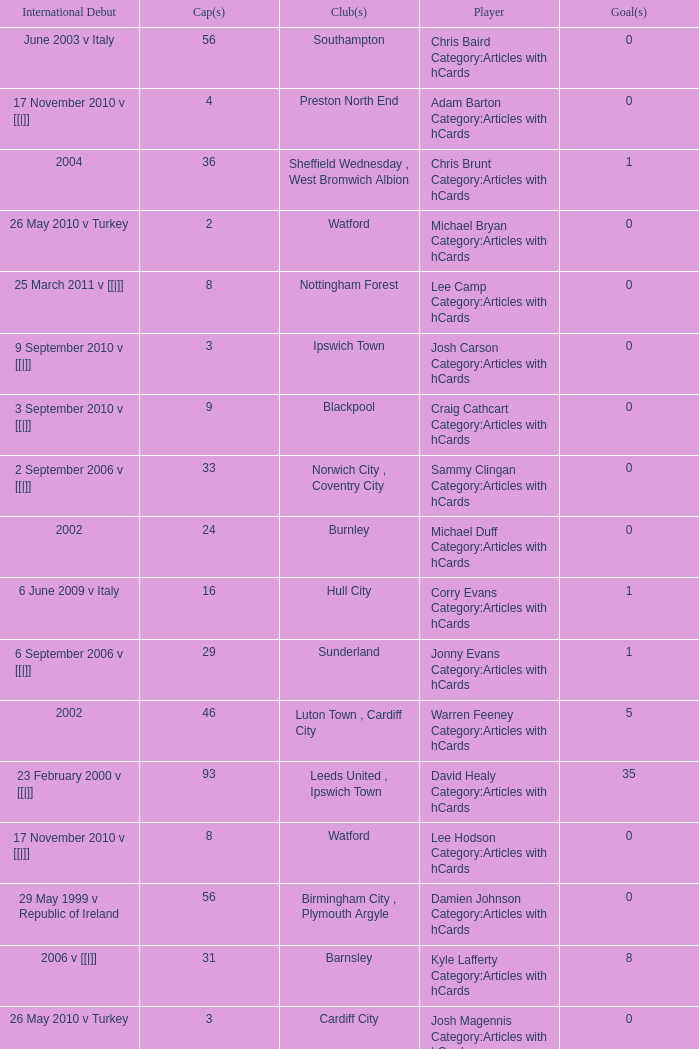How many caps figures for the Doncaster Rovers? 1.0. Help me parse the entirety of this table. {'header': ['International Debut', 'Cap(s)', 'Club(s)', 'Player', 'Goal(s)'], 'rows': [['June 2003 v Italy', '56', 'Southampton', 'Chris Baird Category:Articles with hCards', '0'], ['17 November 2010 v [[|]]', '4', 'Preston North End', 'Adam Barton Category:Articles with hCards', '0'], ['2004', '36', 'Sheffield Wednesday , West Bromwich Albion', 'Chris Brunt Category:Articles with hCards', '1'], ['26 May 2010 v Turkey', '2', 'Watford', 'Michael Bryan Category:Articles with hCards', '0'], ['25 March 2011 v [[|]]', '8', 'Nottingham Forest', 'Lee Camp Category:Articles with hCards', '0'], ['9 September 2010 v [[|]]', '3', 'Ipswich Town', 'Josh Carson Category:Articles with hCards', '0'], ['3 September 2010 v [[|]]', '9', 'Blackpool', 'Craig Cathcart Category:Articles with hCards', '0'], ['2 September 2006 v [[|]]', '33', 'Norwich City , Coventry City', 'Sammy Clingan Category:Articles with hCards', '0'], ['2002', '24', 'Burnley', 'Michael Duff Category:Articles with hCards', '0'], ['6 June 2009 v Italy', '16', 'Hull City', 'Corry Evans Category:Articles with hCards', '1'], ['6 September 2006 v [[|]]', '29', 'Sunderland', 'Jonny Evans Category:Articles with hCards', '1'], ['2002', '46', 'Luton Town , Cardiff City', 'Warren Feeney Category:Articles with hCards', '5'], ['23 February 2000 v [[|]]', '93', 'Leeds United , Ipswich Town', 'David Healy Category:Articles with hCards', '35'], ['17 November 2010 v [[|]]', '8', 'Watford', 'Lee Hodson Category:Articles with hCards', '0'], ['29 May 1999 v Republic of Ireland', '56', 'Birmingham City , Plymouth Argyle', 'Damien Johnson Category:Articles with hCards', '0'], ['2006 v [[|]]', '31', 'Barnsley', 'Kyle Lafferty Category:Articles with hCards', '8'], ['26 May 2010 v Turkey', '3', 'Cardiff City', 'Josh Magennis Category:Articles with hCards', '0'], ['4 June 2005 v [[|]]', '36', 'Leicester City , Ipswich Town', 'Gareth McAuley Category:Articles with hCards', '2'], ['24 March 2007 v [[|]]', '39', 'Barnsley , Scunthorpe United , Peterborough United', 'Grant McCann Category:Articles with hCards', '4'], ['September 2001 v [[|]]', '34', 'Sunderland', 'George McCartney Category:Articles with hCards', '1'], ['21 August 2008 v [[|]]', '16', 'Leicester City , Bristol City', 'Ryan McGivern Category:Articles with hCards', '0'], ['2 June 2012 v [[|]]', '1', 'Coventry City', 'James McPake Category:Articles with hCards', '0'], ['17 November 2010 v [[|]]', '5', 'Millwall', 'Josh McQuoid Category:Articles with hCards', '0'], ['11 August 2010 v [[|]]', '6', 'Coventry City', 'Oliver Norwood Category:Articles with hCards', '0'], ['26 March 2008 v [[|]]', '10', 'Scunthorpe United', "Michael O'Connor Category:Articles with hCards", '0'], ['2007', '13', 'Scunthorpe United , Burnley', 'Martin Paterson Category:Articles with hCards', '0'], ['3 March 2010 v [[|]]', '5', 'Plymouth Argyle', 'Rory Patterson Category:Articles with hCards', '1'], ['15 November 2005 v [[|]]', '9', 'Doncaster Rovers', 'Dean Shiels Category:Articles with hCards', '0'], ['7 September 2005 v England', '11', 'Bristol City', 'Ivan Sproule Category:Articles with hCards', '1'], ['27 March 1999 v [[|]]', '88', 'Birmingham City', 'Maik Taylor Category:Articles with hCards', '0'], ['9 February 2011 v [[|]]', '2', 'Watford', 'Adam Thompson Category:Articles with hCards', '0']]} 